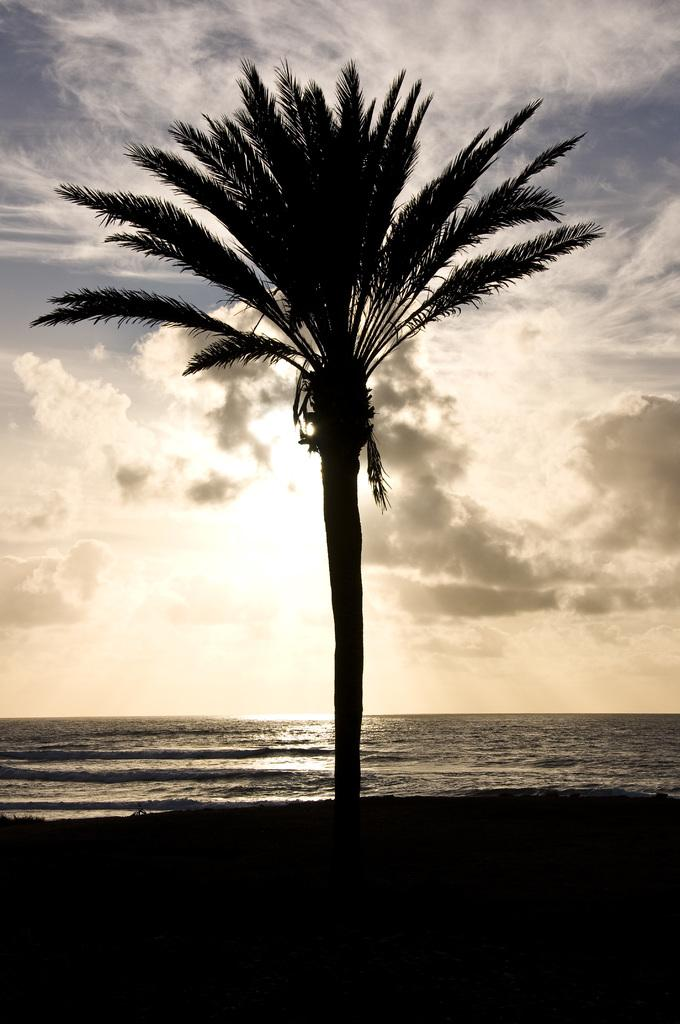What type of plant can be seen in the image? There is a tree in the image. What natural element is visible in the image besides the tree? There is water visible in the image. What colors are present in the sky in the image? The sky is blue and white in color. What caption is written on the image? There is no caption present in the image; it is a photograph of a tree, water, and the sky. 